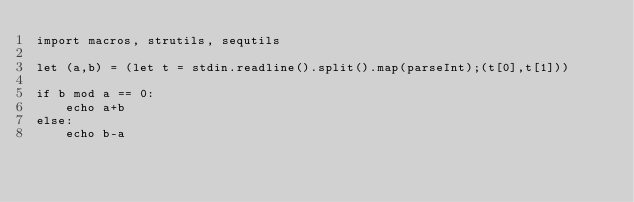Convert code to text. <code><loc_0><loc_0><loc_500><loc_500><_Nim_>import macros, strutils, sequtils

let (a,b) = (let t = stdin.readline().split().map(parseInt);(t[0],t[1]))

if b mod a == 0:
    echo a+b
else:
    echo b-a</code> 